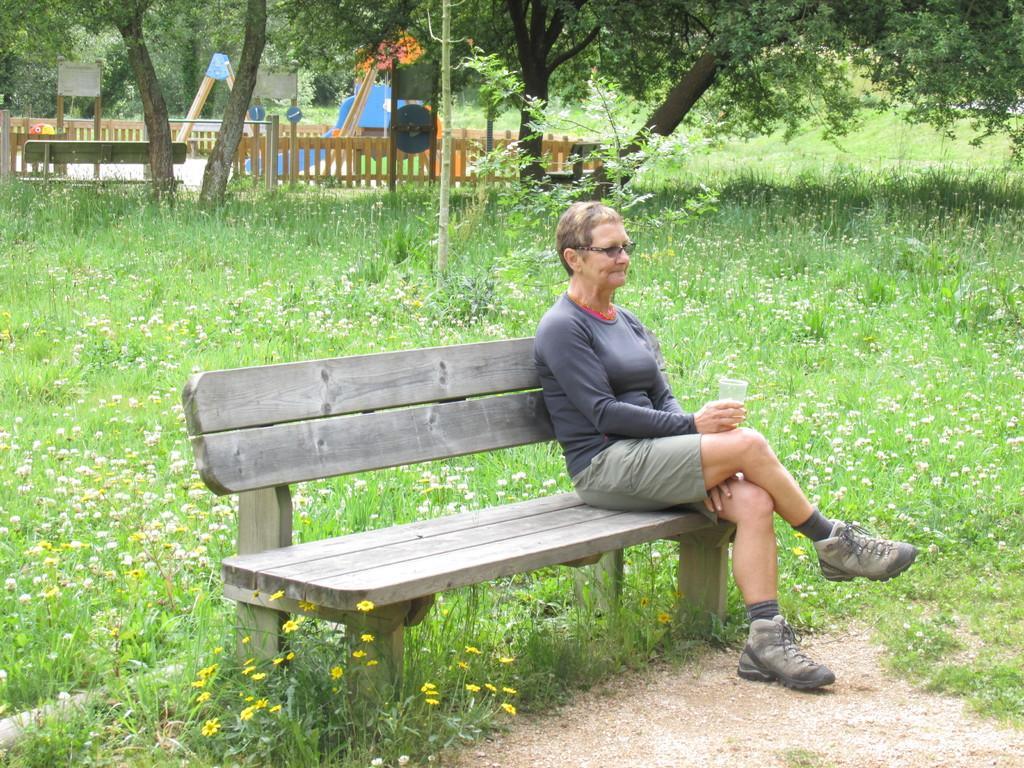Please provide a concise description of this image. In the picture I can see a woman is sitting on the wooden bench and holding a glass in the hand. In the background I can see flower plants, trees, benches, poles, fence and some other objects on the ground. 